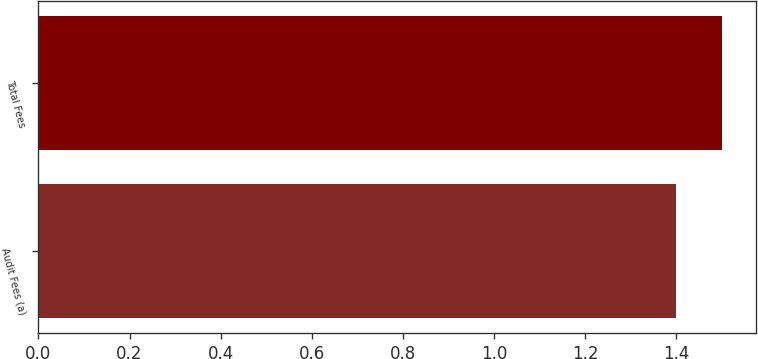Convert chart. <chart><loc_0><loc_0><loc_500><loc_500><bar_chart><fcel>Audit Fees (a)<fcel>Total Fees<nl><fcel>1.4<fcel>1.5<nl></chart> 